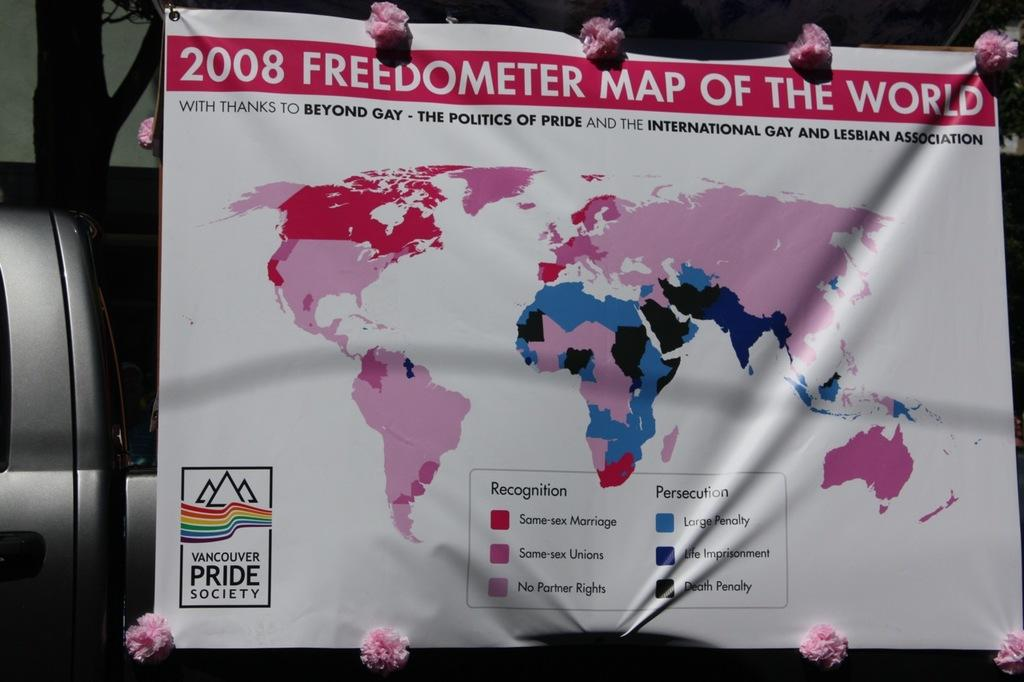<image>
Write a terse but informative summary of the picture. A map of the world with the title 2008 freedometer map of the world. 